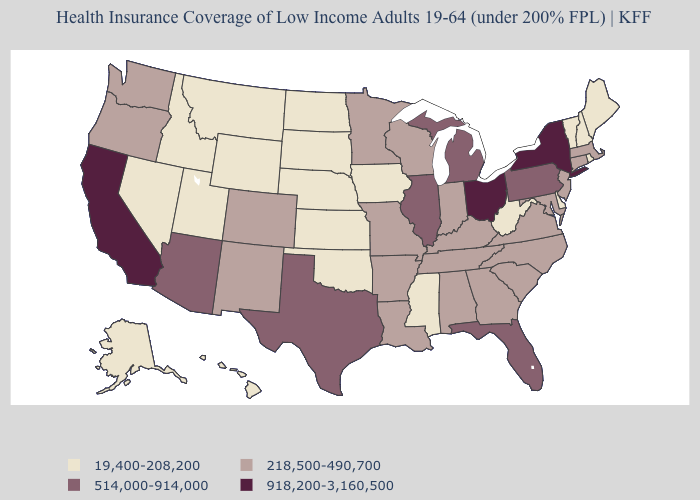Does Kentucky have a lower value than Washington?
Be succinct. No. Name the states that have a value in the range 19,400-208,200?
Write a very short answer. Alaska, Delaware, Hawaii, Idaho, Iowa, Kansas, Maine, Mississippi, Montana, Nebraska, Nevada, New Hampshire, North Dakota, Oklahoma, Rhode Island, South Dakota, Utah, Vermont, West Virginia, Wyoming. Which states have the lowest value in the West?
Quick response, please. Alaska, Hawaii, Idaho, Montana, Nevada, Utah, Wyoming. What is the value of Pennsylvania?
Be succinct. 514,000-914,000. Does New York have the highest value in the USA?
Keep it brief. Yes. Does the first symbol in the legend represent the smallest category?
Write a very short answer. Yes. What is the highest value in states that border North Carolina?
Quick response, please. 218,500-490,700. What is the lowest value in states that border Colorado?
Keep it brief. 19,400-208,200. What is the highest value in the USA?
Quick response, please. 918,200-3,160,500. What is the value of Tennessee?
Concise answer only. 218,500-490,700. Does Washington have the lowest value in the West?
Give a very brief answer. No. How many symbols are there in the legend?
Write a very short answer. 4. What is the value of Tennessee?
Be succinct. 218,500-490,700. 